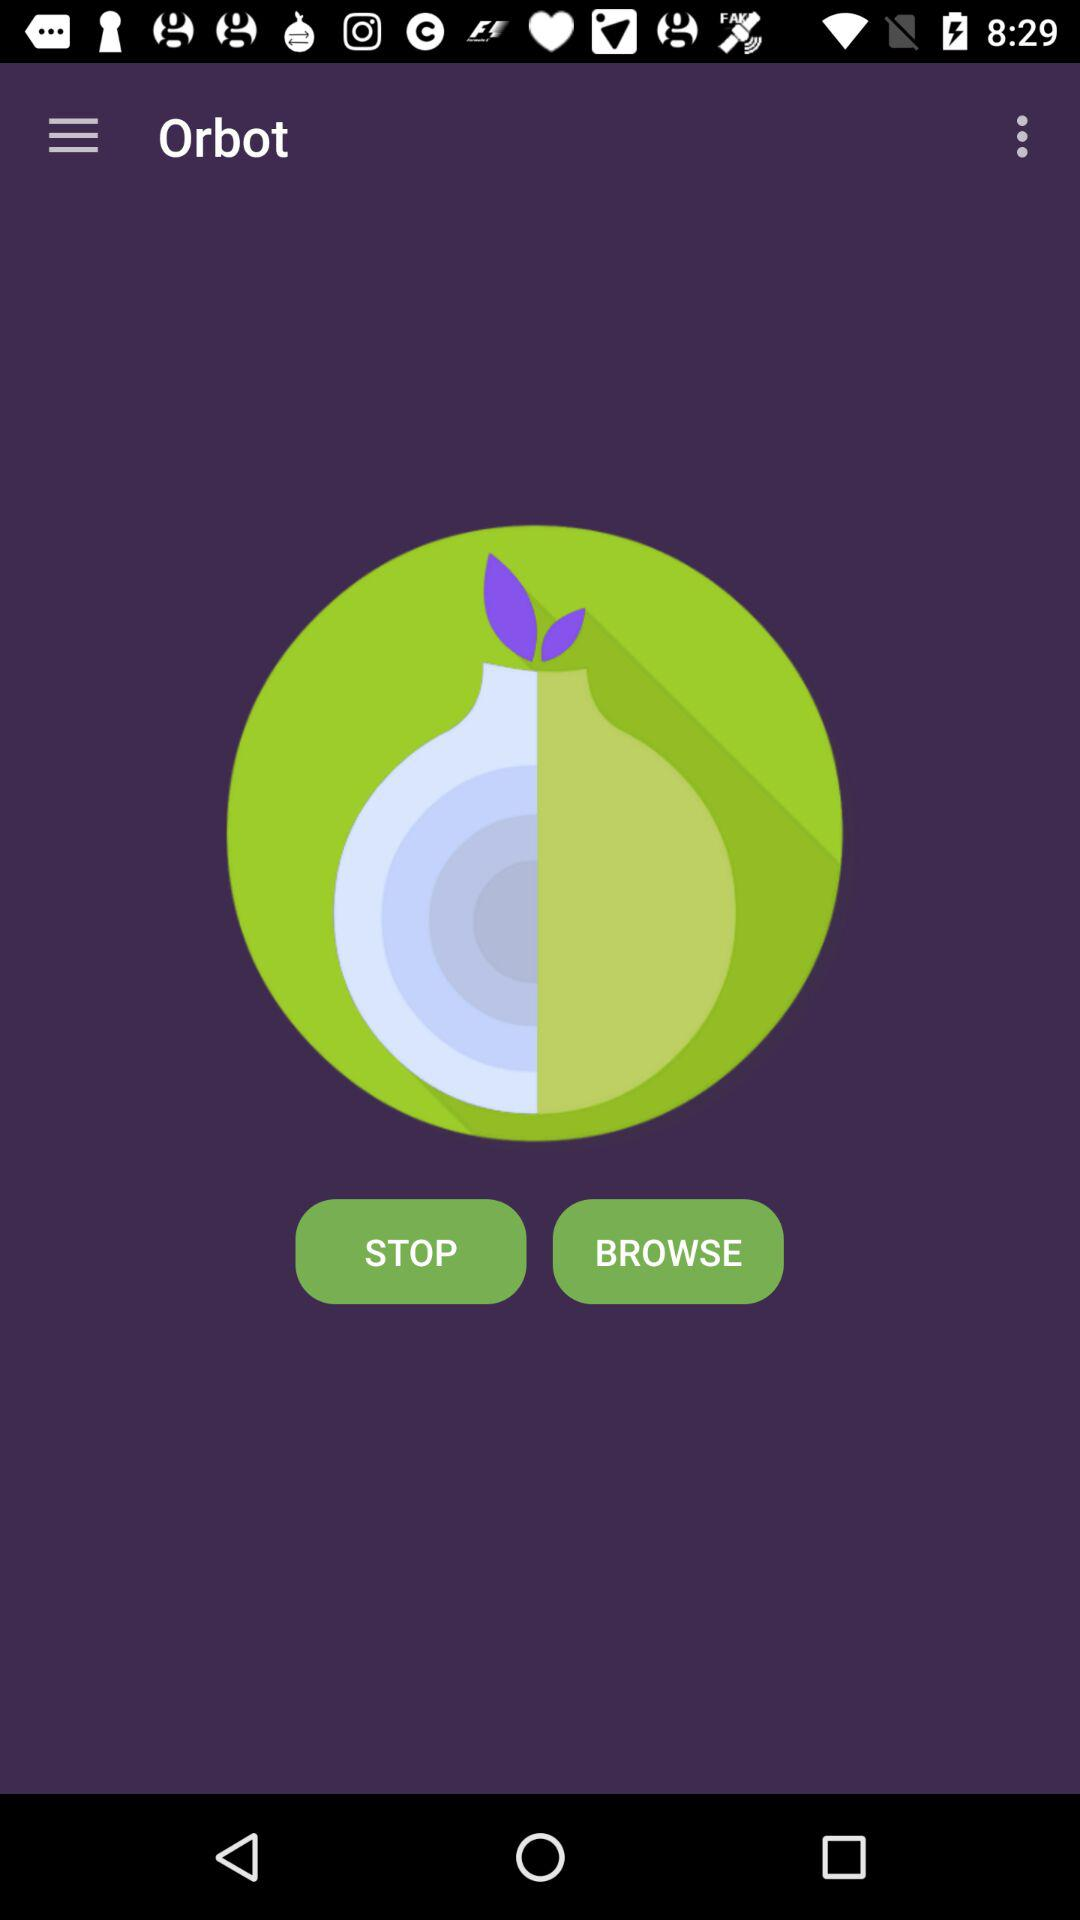What is the app name? The app name is "Orbot". 